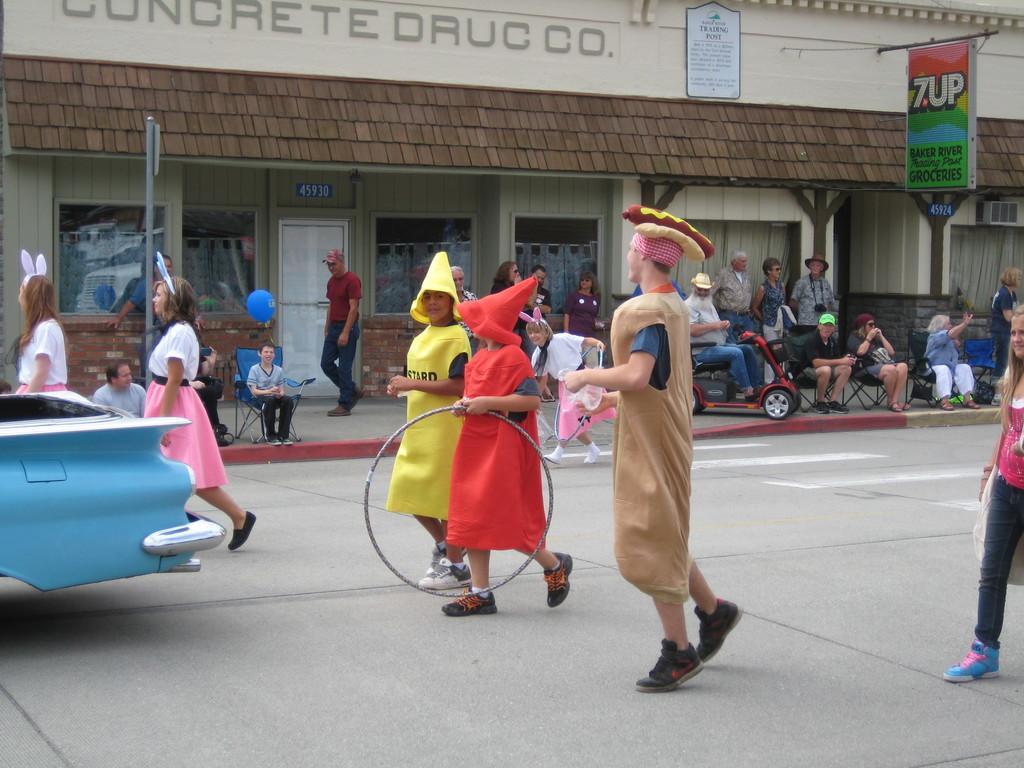Please provide a concise description of this image. In the image we can see there are people standing on the road and they are wearing costumes. There is a car parked on the road and there are few people sitting on the chairs. Behind there is a building and there are hoardings. 